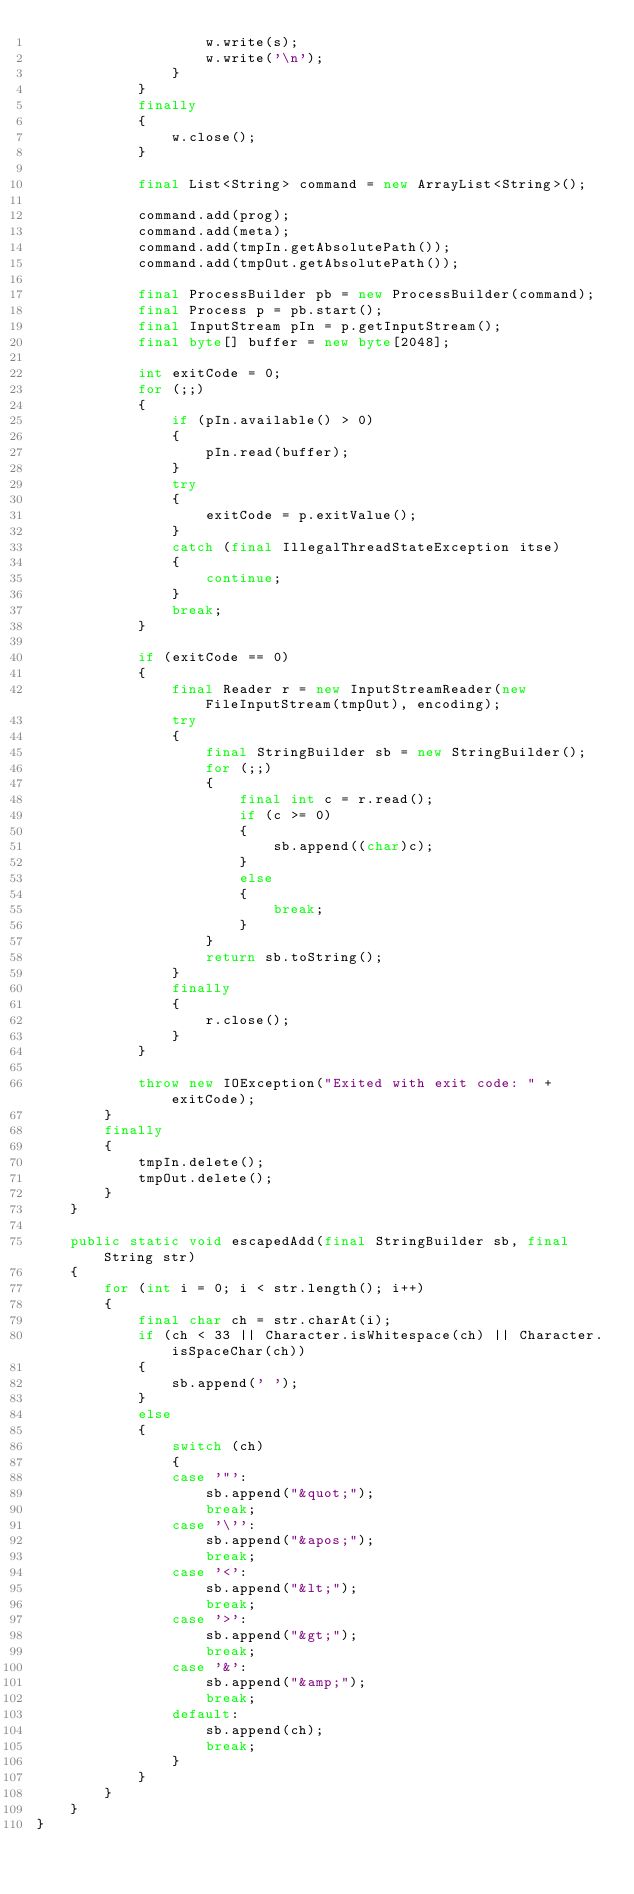Convert code to text. <code><loc_0><loc_0><loc_500><loc_500><_Java_>                    w.write(s);
                    w.write('\n');
                }
            }
            finally
            {
                w.close();
            }

            final List<String> command = new ArrayList<String>();

            command.add(prog);
            command.add(meta);
            command.add(tmpIn.getAbsolutePath());
            command.add(tmpOut.getAbsolutePath());

            final ProcessBuilder pb = new ProcessBuilder(command);
            final Process p = pb.start();
            final InputStream pIn = p.getInputStream();
            final byte[] buffer = new byte[2048];

            int exitCode = 0;
            for (;;)
            {
                if (pIn.available() > 0)
                {
                    pIn.read(buffer);
                }
                try
                {
                    exitCode = p.exitValue();
                }
                catch (final IllegalThreadStateException itse)
                {
                    continue;
                }
                break;
            }

            if (exitCode == 0)
            {
                final Reader r = new InputStreamReader(new FileInputStream(tmpOut), encoding);
                try
                {
                    final StringBuilder sb = new StringBuilder();
                    for (;;)
                    {
                        final int c = r.read();
                        if (c >= 0)
                        {
                            sb.append((char)c);
                        }
                        else
                        {
                            break;
                        }
                    }
                    return sb.toString();
                }
                finally
                {
                    r.close();
                }
            }

            throw new IOException("Exited with exit code: " + exitCode);
        }
        finally
        {
            tmpIn.delete();
            tmpOut.delete();
        }
    }

    public static void escapedAdd(final StringBuilder sb, final String str)
    {
        for (int i = 0; i < str.length(); i++)
        {
            final char ch = str.charAt(i);
            if (ch < 33 || Character.isWhitespace(ch) || Character.isSpaceChar(ch))
            {
                sb.append(' ');
            }
            else
            {
                switch (ch)
                {
                case '"':
                    sb.append("&quot;");
                    break;
                case '\'':
                    sb.append("&apos;");
                    break;
                case '<':
                    sb.append("&lt;");
                    break;
                case '>':
                    sb.append("&gt;");
                    break;
                case '&':
                    sb.append("&amp;");
                    break;
                default:
                    sb.append(ch);
                    break;
                }
            }
        }
    }
}
</code> 